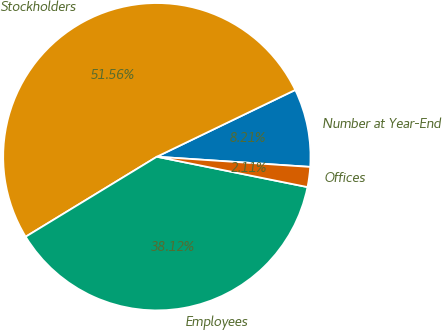<chart> <loc_0><loc_0><loc_500><loc_500><pie_chart><fcel>Number at Year-End<fcel>Stockholders<fcel>Employees<fcel>Offices<nl><fcel>8.21%<fcel>51.56%<fcel>38.12%<fcel>2.11%<nl></chart> 